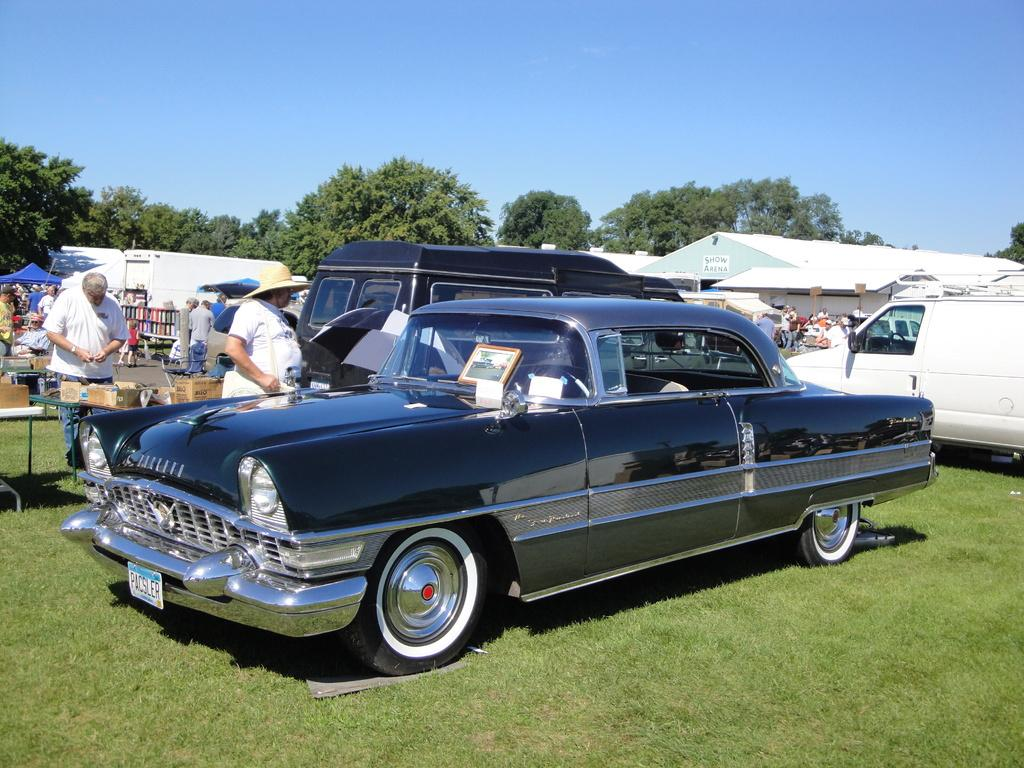What is the main subject in the center of the image? There is a car on the grass in the center of the image. What can be seen in the background of the image? In the background of the image, there are cars, persons, tents, sheds, a road, objects arranged in shelves, trees, and the sky. How many cars are visible in the image? There is one car in the center of the image and multiple cars in the background, so there are at least two cars visible. Can you tell me how many balloons are tied to the car in the image? There are no balloons tied to the car in the image. Is the queen present in the image? There is no mention of a queen or any royal figure in the image. 